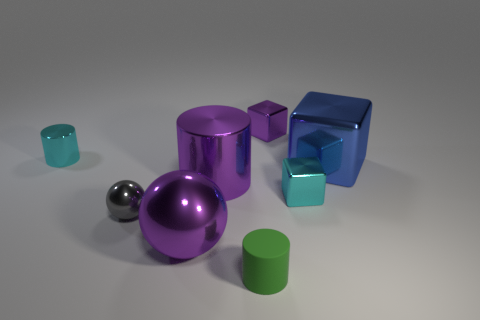What is the shape of the tiny metallic thing that is the same color as the large cylinder?
Your answer should be compact. Cube. Do the large blue metallic object that is behind the green thing and the small cyan metal object in front of the small metallic cylinder have the same shape?
Make the answer very short. Yes. Are there an equal number of green rubber objects that are to the right of the blue cube and metallic cylinders?
Your answer should be compact. No. There is a small metal cube that is to the right of the tiny purple block; are there any purple objects that are right of it?
Make the answer very short. No. Is there any other thing that has the same color as the large ball?
Offer a very short reply. Yes. Is the material of the tiny thing that is behind the small cyan cylinder the same as the gray ball?
Provide a short and direct response. Yes. Are there an equal number of metal objects behind the big blue thing and big purple spheres that are in front of the purple metallic ball?
Your answer should be very brief. No. What is the size of the cyan metallic object left of the metal block behind the blue metal cube?
Your answer should be very brief. Small. There is a object that is on the left side of the purple ball and to the right of the cyan cylinder; what material is it?
Provide a succinct answer. Metal. How many other objects are the same size as the purple shiny ball?
Ensure brevity in your answer.  2. 